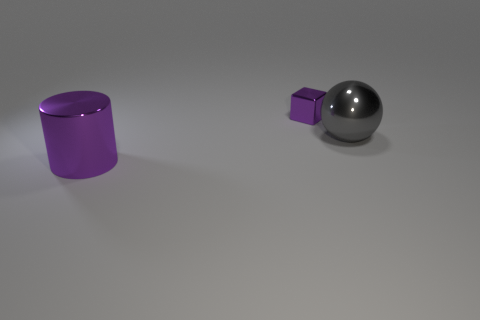Add 1 tiny cyan matte spheres. How many objects exist? 4 Subtract all balls. How many objects are left? 2 Add 3 big brown metallic objects. How many big brown metallic objects exist? 3 Subtract 0 purple spheres. How many objects are left? 3 Subtract all big purple shiny cylinders. Subtract all metallic balls. How many objects are left? 1 Add 2 large gray metal spheres. How many large gray metal spheres are left? 3 